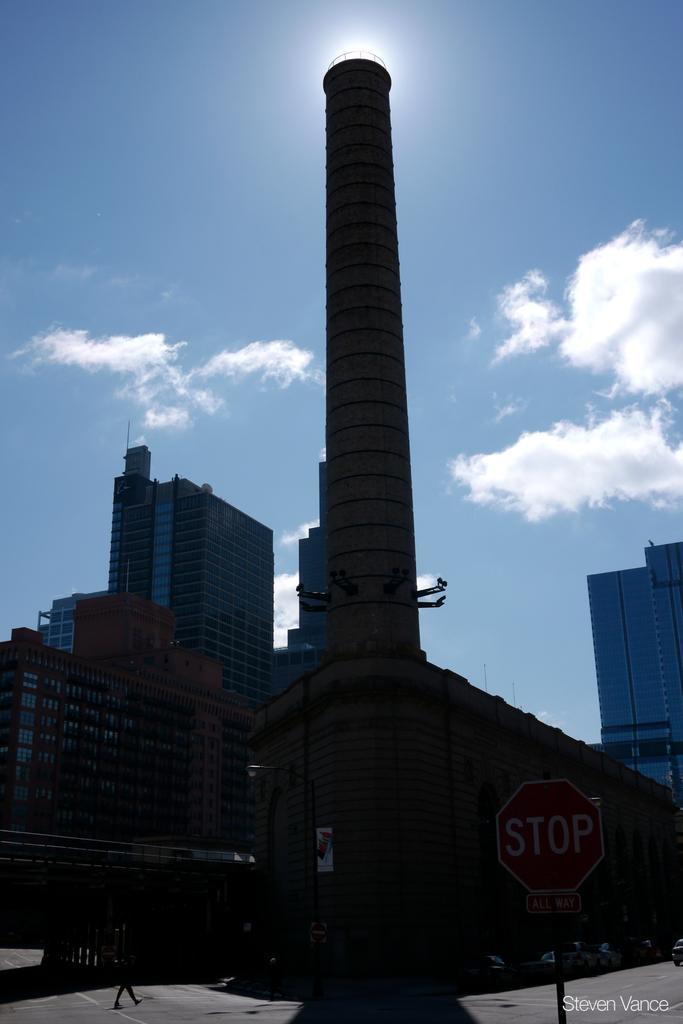In one or two sentences, can you explain what this image depicts? This looks like a tower. I can see a signboard, which is attached to the pole. These are the buildings. I can see a person walking. These are the clouds in the sky. At the bottom right side of the image, I can see the watermark. 